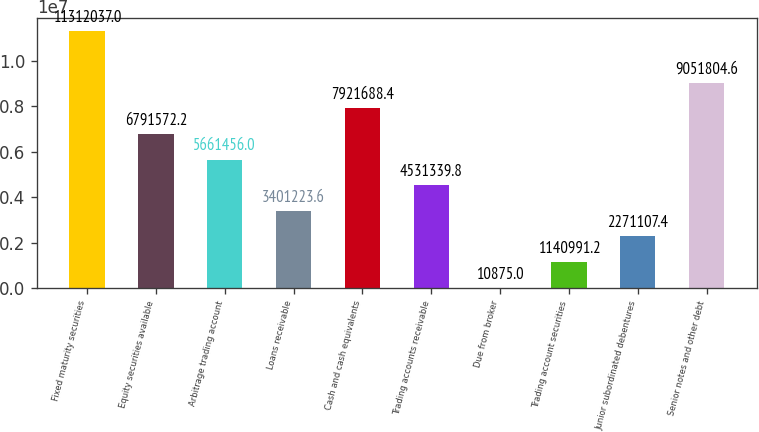<chart> <loc_0><loc_0><loc_500><loc_500><bar_chart><fcel>Fixed maturity securities<fcel>Equity securities available<fcel>Arbitrage trading account<fcel>Loans receivable<fcel>Cash and cash equivalents<fcel>Trading accounts receivable<fcel>Due from broker<fcel>Trading account securities<fcel>Junior subordinated debentures<fcel>Senior notes and other debt<nl><fcel>1.1312e+07<fcel>6.79157e+06<fcel>5.66146e+06<fcel>3.40122e+06<fcel>7.92169e+06<fcel>4.53134e+06<fcel>10875<fcel>1.14099e+06<fcel>2.27111e+06<fcel>9.0518e+06<nl></chart> 